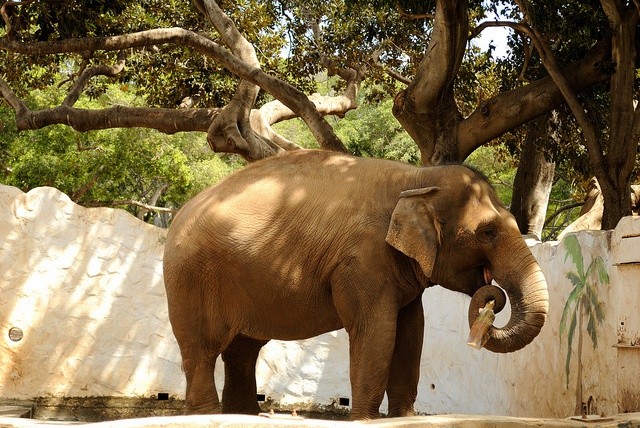Describe the objects in this image and their specific colors. I can see a elephant in black, maroon, and olive tones in this image. 